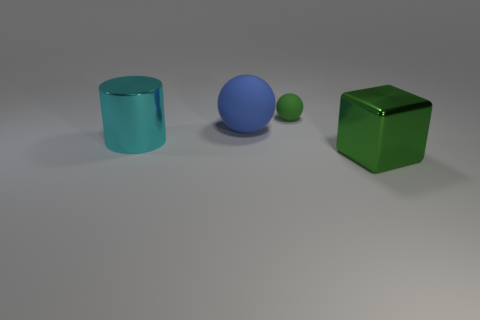Are there any cyan metallic cylinders behind the small green matte sphere?
Provide a short and direct response. No. Do the cyan metal thing and the green object on the left side of the large green cube have the same size?
Your answer should be compact. No. There is another object that is the same shape as the blue rubber thing; what size is it?
Your answer should be compact. Small. Is there anything else that is the same material as the large green thing?
Give a very brief answer. Yes. Do the green thing in front of the blue thing and the green object that is behind the big blue sphere have the same size?
Make the answer very short. No. What number of large things are blue objects or purple metal cubes?
Offer a very short reply. 1. How many green objects are behind the cyan cylinder and in front of the cyan shiny object?
Your answer should be very brief. 0. Does the large blue thing have the same material as the ball right of the large ball?
Ensure brevity in your answer.  Yes. What number of red things are tiny matte things or metal objects?
Provide a short and direct response. 0. Is there a cyan metallic object of the same size as the blue rubber thing?
Keep it short and to the point. Yes. 